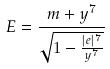<formula> <loc_0><loc_0><loc_500><loc_500>E = \frac { m + y ^ { 7 } } { \sqrt { 1 - \frac { | e | ^ { 7 } } { y ^ { 7 } } } }</formula> 